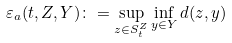<formula> <loc_0><loc_0><loc_500><loc_500>\varepsilon _ { a } ( t , Z , Y ) \colon = \sup _ { z \in S _ { t } ^ { Z } } \inf _ { y \in Y } d ( z , y )</formula> 